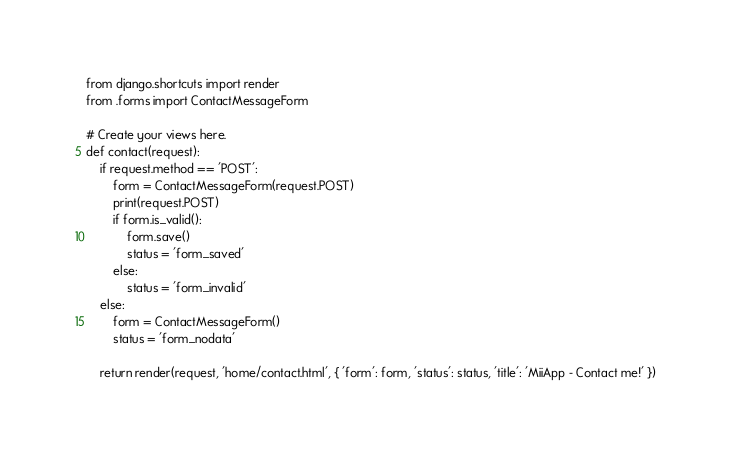Convert code to text. <code><loc_0><loc_0><loc_500><loc_500><_Python_>from django.shortcuts import render
from .forms import ContactMessageForm

# Create your views here.
def contact(request):
    if request.method == 'POST':
        form = ContactMessageForm(request.POST)
        print(request.POST)
        if form.is_valid():
            form.save()
            status = 'form_saved'
        else:
            status = 'form_invalid'
    else:
        form = ContactMessageForm()
        status = 'form_nodata'

    return render(request, 'home/contact.html', { 'form': form, 'status': status, 'title': 'MiiApp - Contact me!' })</code> 